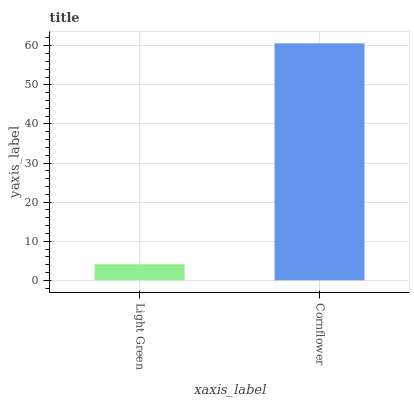Is Light Green the minimum?
Answer yes or no. Yes. Is Cornflower the maximum?
Answer yes or no. Yes. Is Cornflower the minimum?
Answer yes or no. No. Is Cornflower greater than Light Green?
Answer yes or no. Yes. Is Light Green less than Cornflower?
Answer yes or no. Yes. Is Light Green greater than Cornflower?
Answer yes or no. No. Is Cornflower less than Light Green?
Answer yes or no. No. Is Cornflower the high median?
Answer yes or no. Yes. Is Light Green the low median?
Answer yes or no. Yes. Is Light Green the high median?
Answer yes or no. No. Is Cornflower the low median?
Answer yes or no. No. 